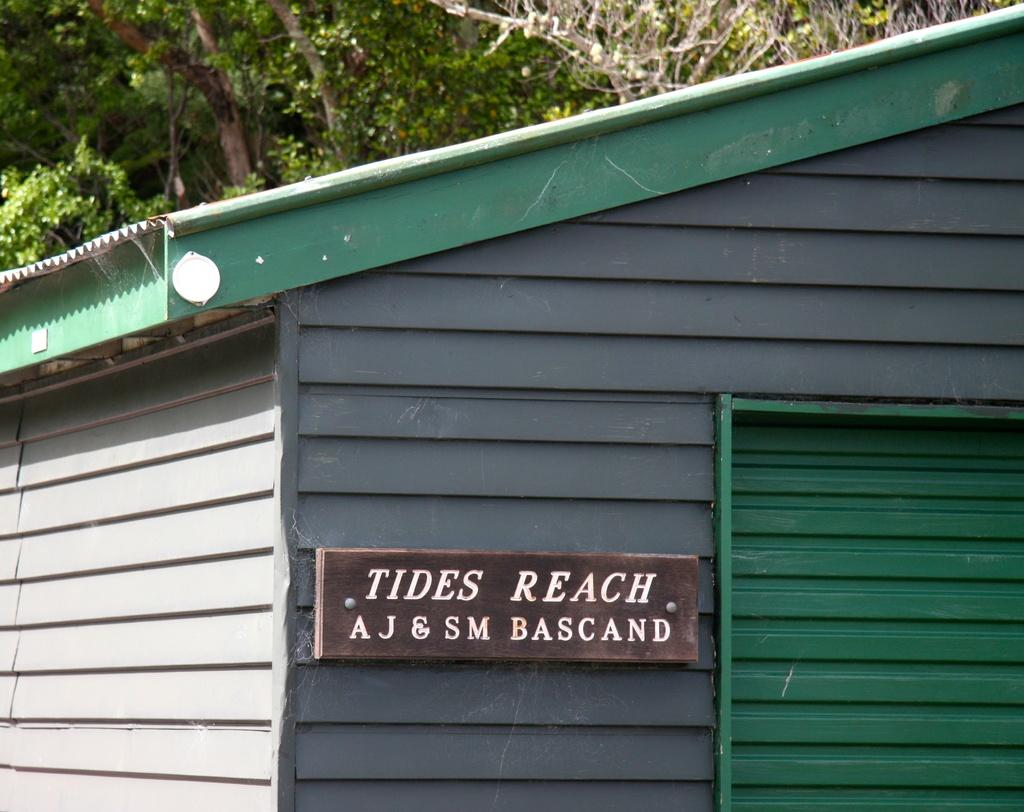What type of structure is in the image? There is a shelter in the image. What is located in front of the shelter? There is a board with text in front of the shelter. What type of vegetation can be seen in the image? Plants and trees are visible in the image. How many hands are visible on the board with text in the image? There are no hands visible on the board with text in the image, as it only contains written information. 